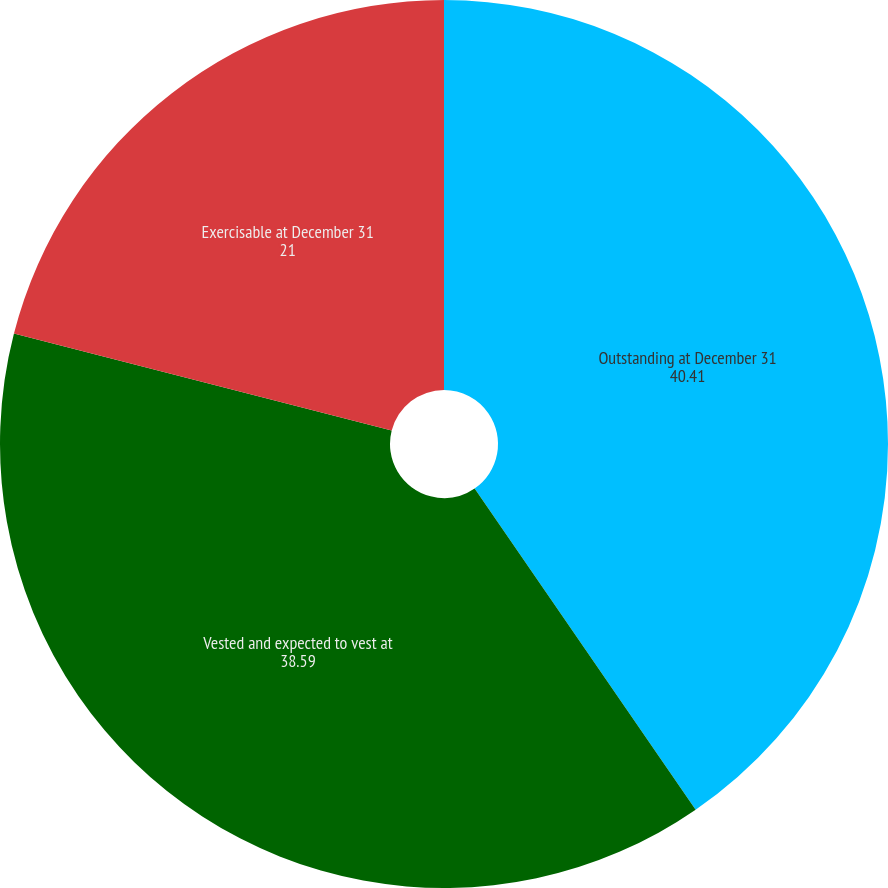<chart> <loc_0><loc_0><loc_500><loc_500><pie_chart><fcel>Outstanding at December 31<fcel>Vested and expected to vest at<fcel>Exercisable at December 31<nl><fcel>40.41%<fcel>38.59%<fcel>21.0%<nl></chart> 